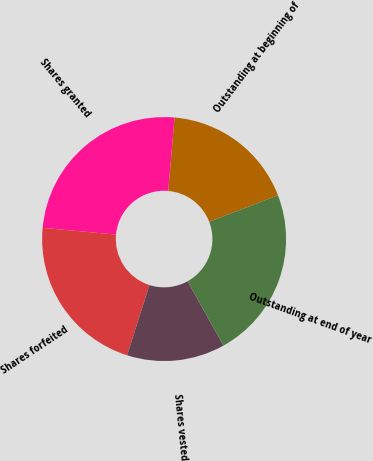<chart> <loc_0><loc_0><loc_500><loc_500><pie_chart><fcel>Outstanding at beginning of<fcel>Shares granted<fcel>Shares forfeited<fcel>Shares vested<fcel>Outstanding at end of year<nl><fcel>17.8%<fcel>24.9%<fcel>21.56%<fcel>12.99%<fcel>22.75%<nl></chart> 